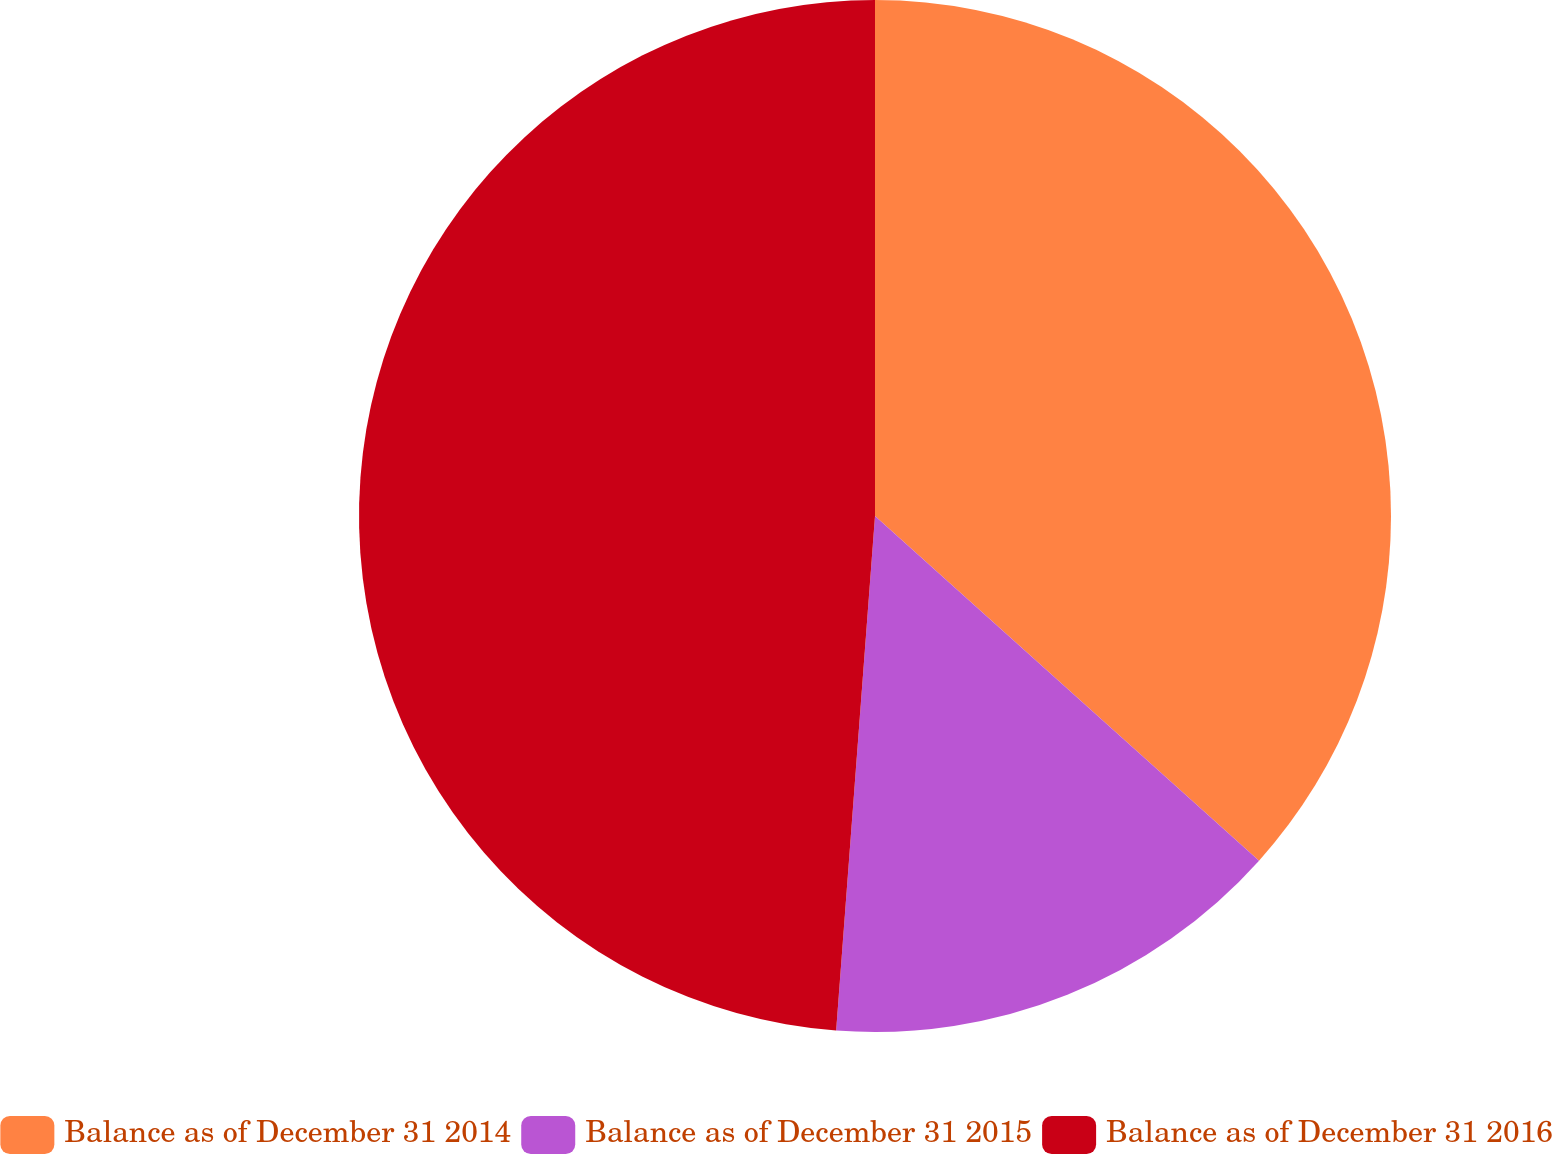Convert chart to OTSL. <chart><loc_0><loc_0><loc_500><loc_500><pie_chart><fcel>Balance as of December 31 2014<fcel>Balance as of December 31 2015<fcel>Balance as of December 31 2016<nl><fcel>36.64%<fcel>14.56%<fcel>48.8%<nl></chart> 